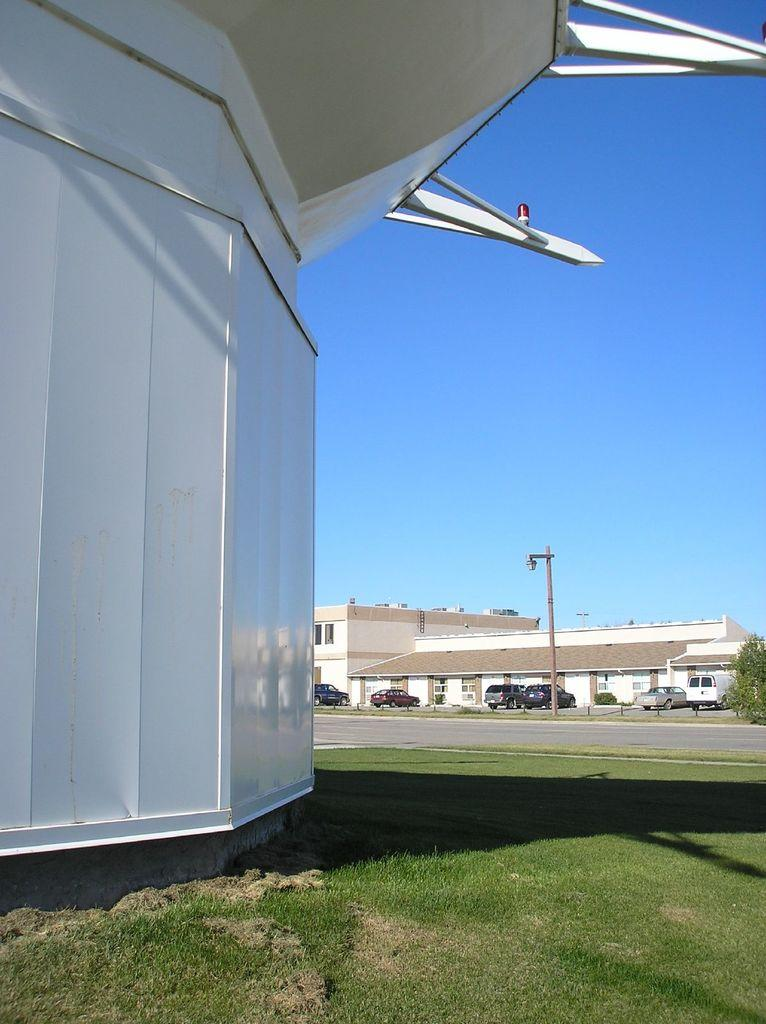What type of vegetation is present in the image? There is grass in the image. What type of structures can be seen in the image? There are buildings in the image. What can be seen in the background of the image? There are vehicles and a pole in the background of the image. Are there any natural elements visible in the background of the image? Yes, there is a tree in the background of the image. Can you see any blood stains on the grass in the image? There is no blood present in the image; it features grass, buildings, vehicles, a pole, and a tree. Is there a dock visible in the image? There is no dock present in the image. 